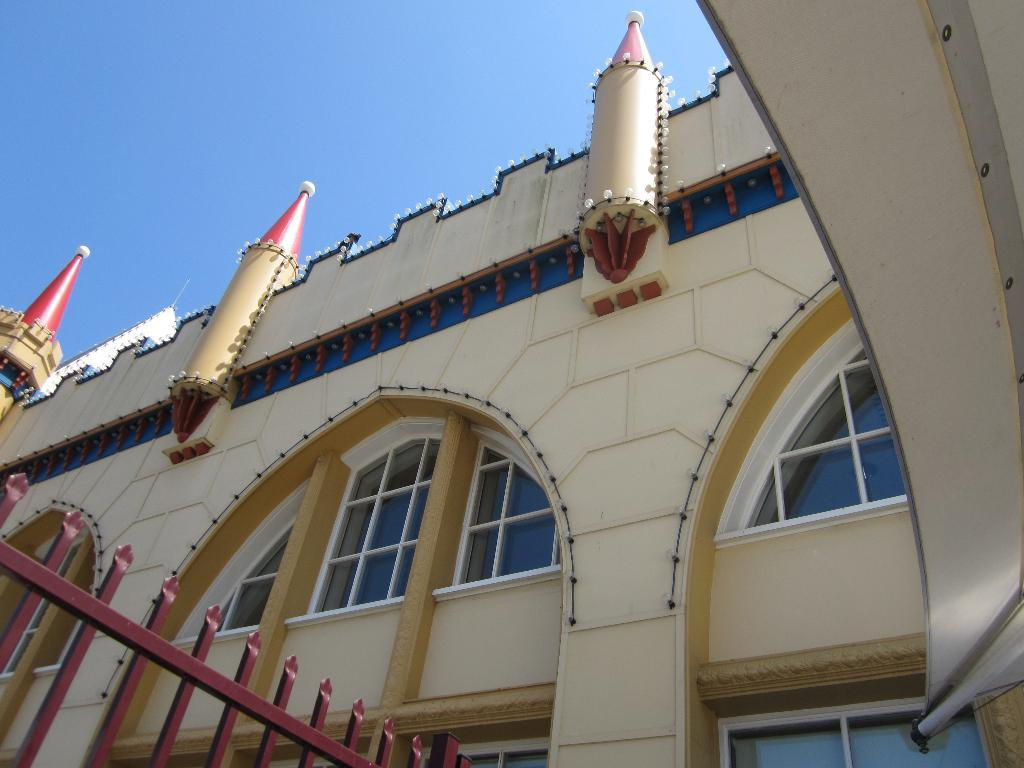What type of structure is present in the image? There is a building in the image. What is located at the bottom of the image? There is a fence at the bottom of the image. What can be seen at the top of the image? The sky is visible at the top of the image. What color is the orange hanging from the pipe in the image? There is no orange or pipe present in the image. 